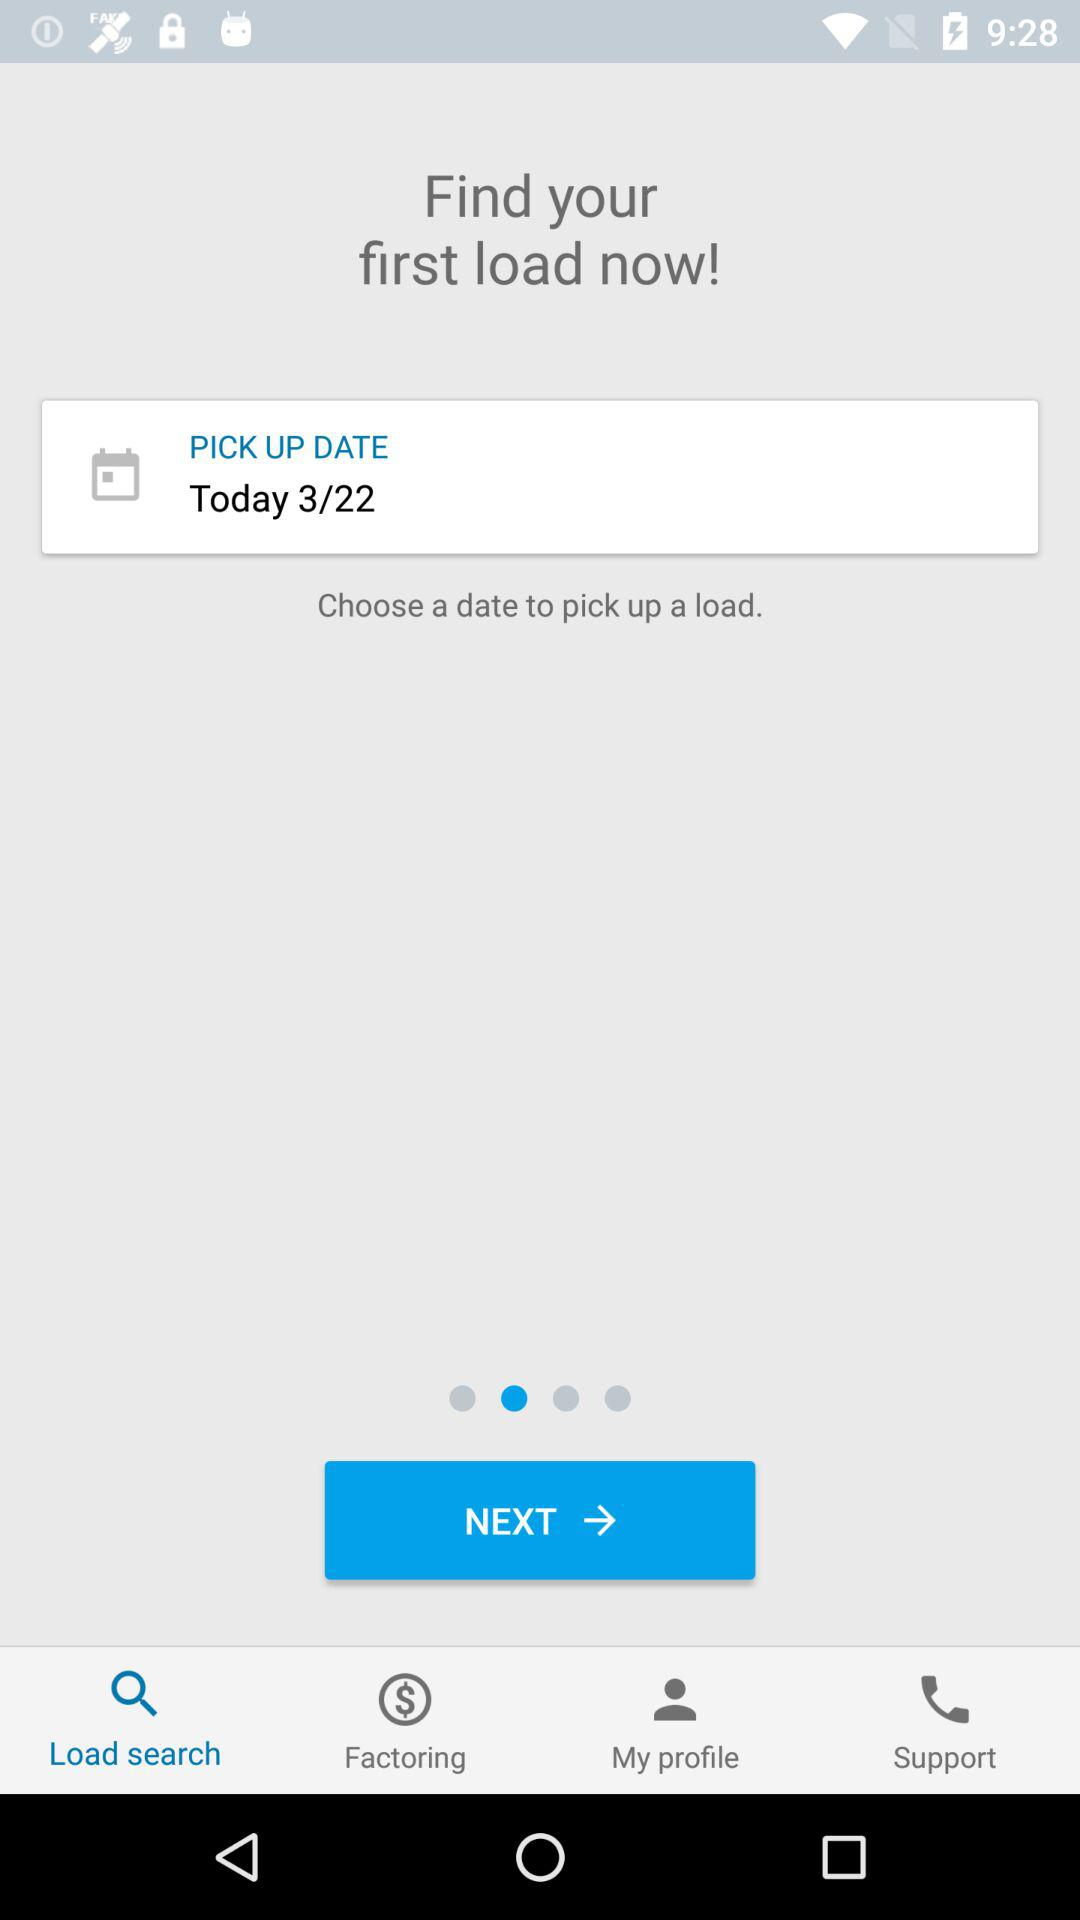What pickup date has been chosen? The selected pickup date, as shown in the application interface, is today, March 22. This date is chosen in the dropdown menu under 'PICK UP DATE', indicating when the load is scheduled to be picked up. 